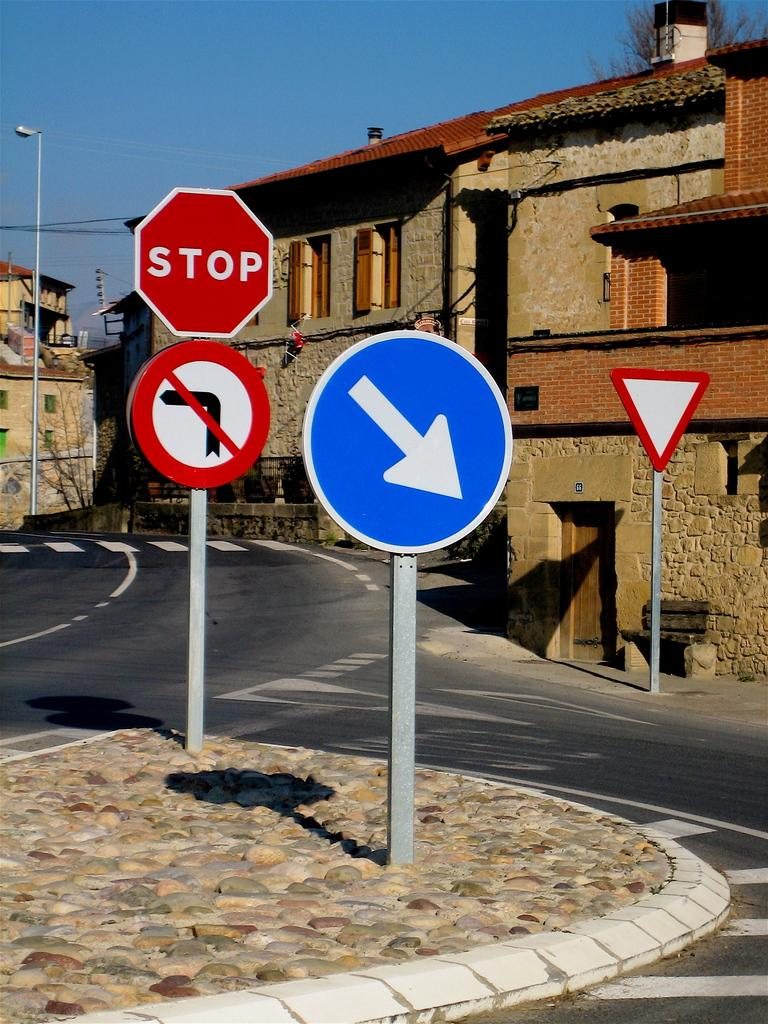<image>
Provide a brief description of the given image. A street with several signs including one that says stop and one that has an arrow pointing down. 